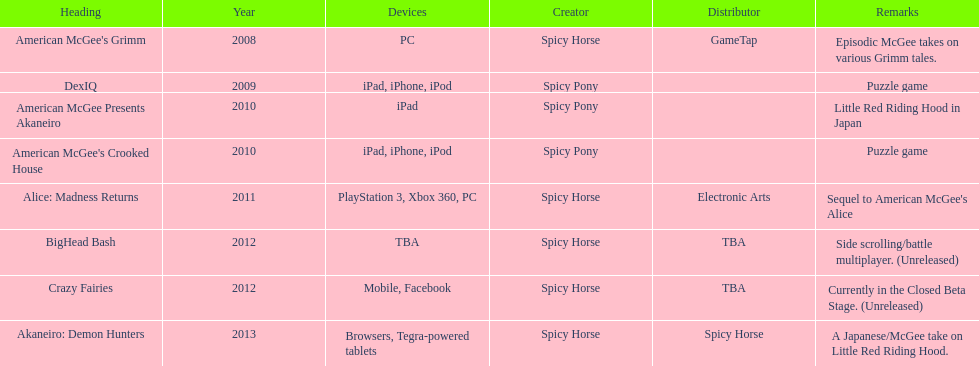Spicy pony released a total of three games; their game, "american mcgee's crooked house" was released on which platforms? Ipad, iphone, ipod. 